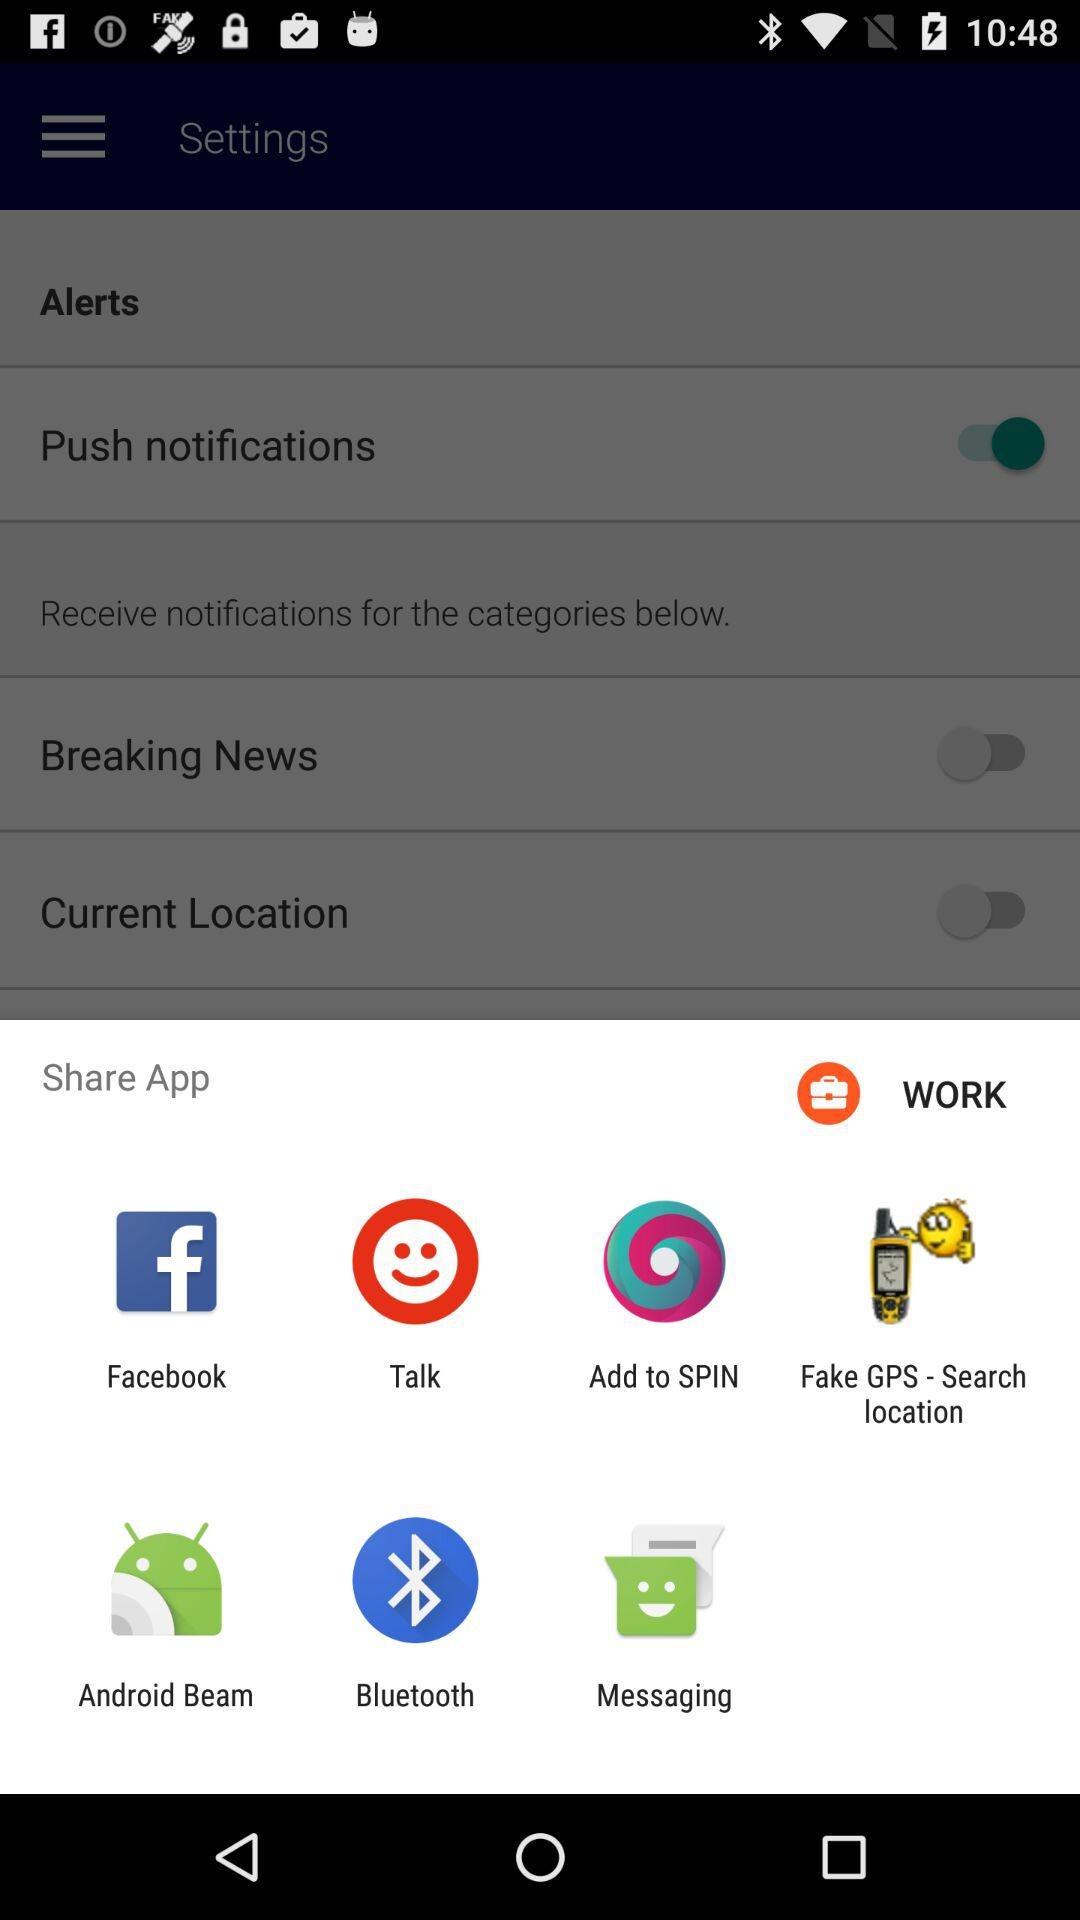What is the status of the push notifications right now? The status is on. 